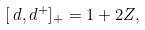Convert formula to latex. <formula><loc_0><loc_0><loc_500><loc_500>[ \, d , d ^ { + } ] _ { + } = 1 + 2 Z ,</formula> 